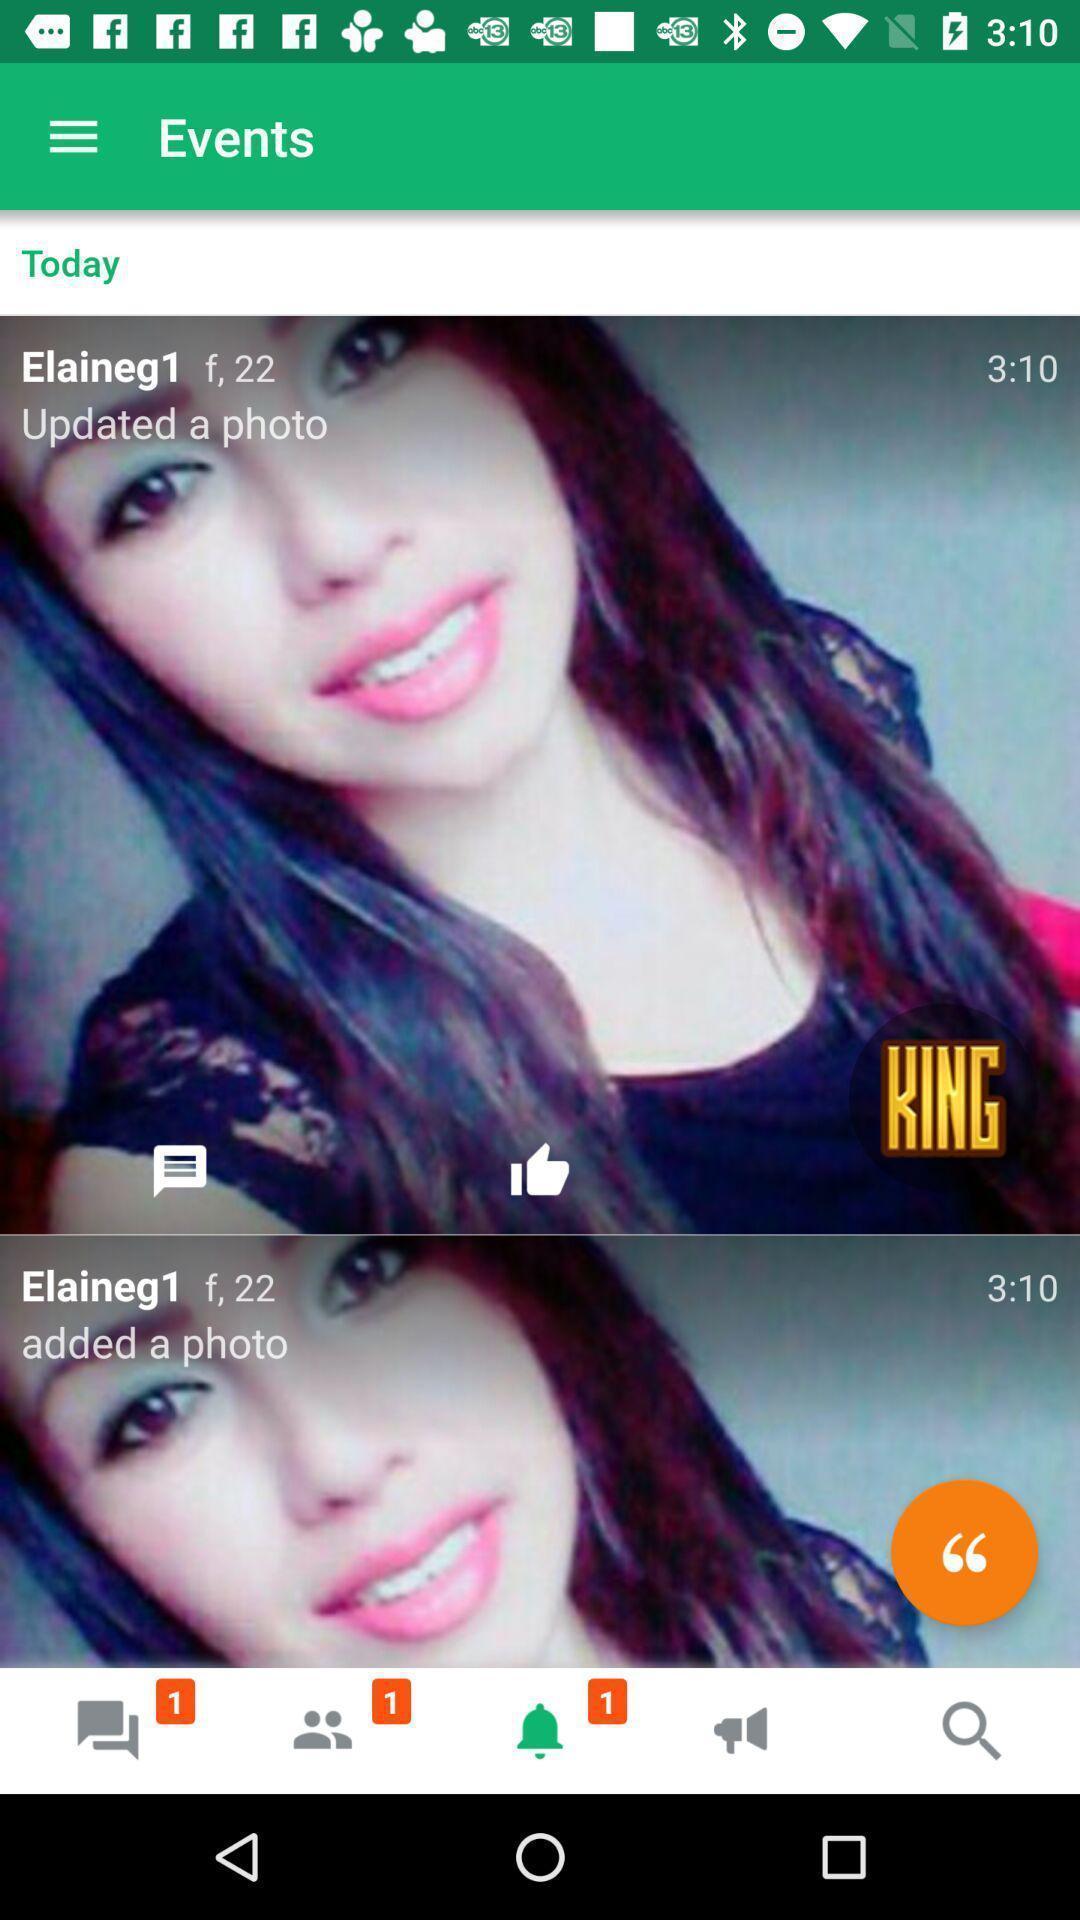Please provide a description for this image. Screen shows a picture of latest events. 